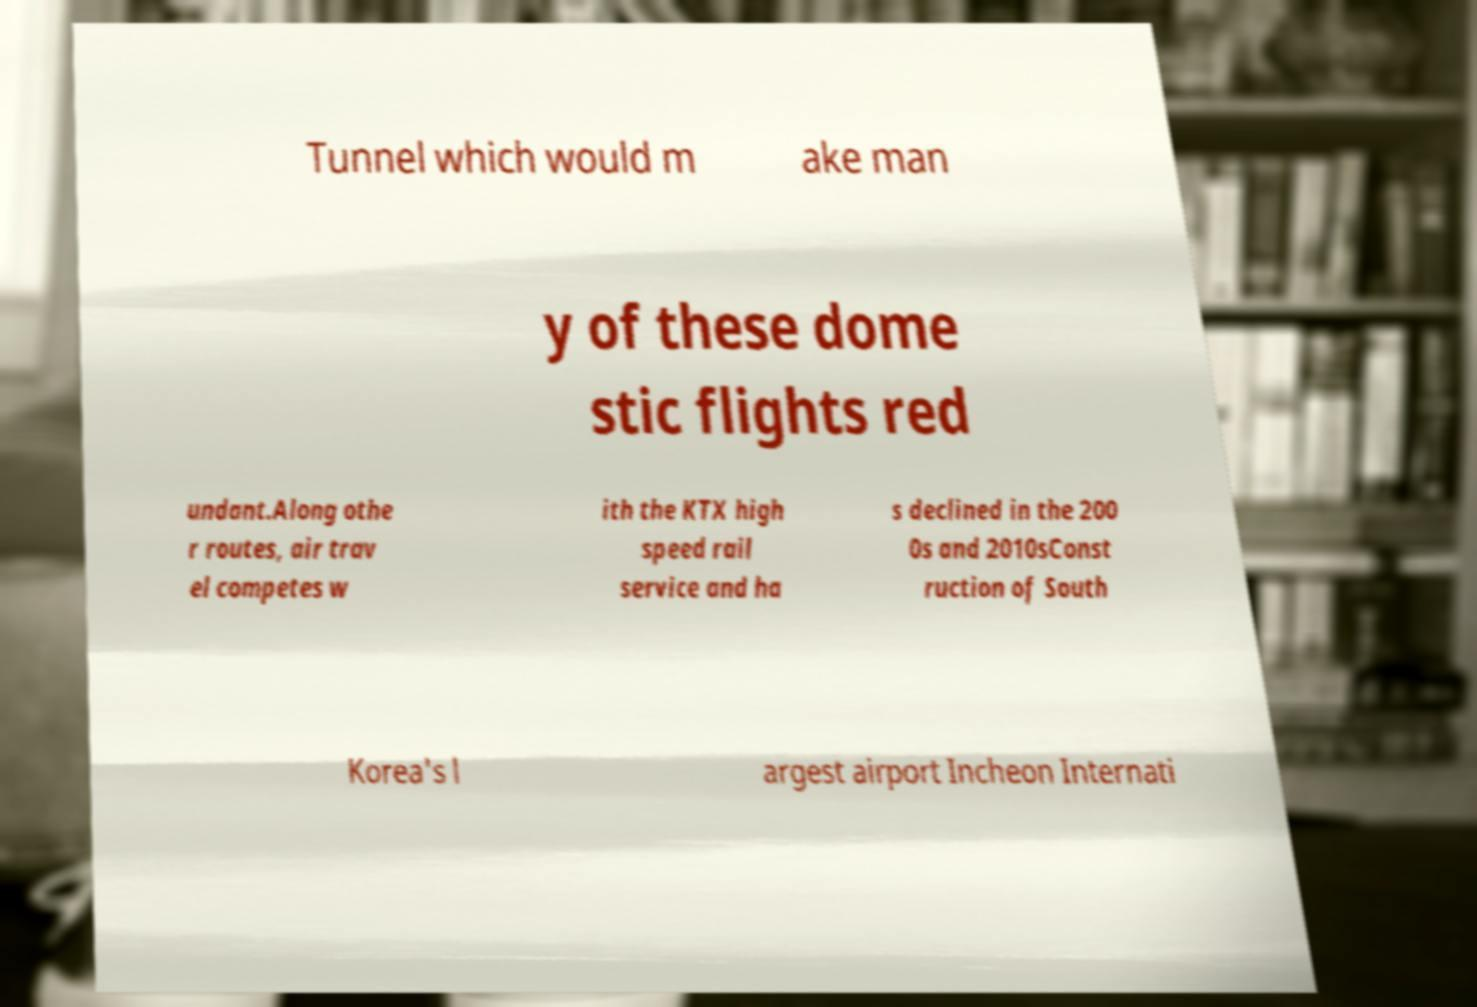What messages or text are displayed in this image? I need them in a readable, typed format. Tunnel which would m ake man y of these dome stic flights red undant.Along othe r routes, air trav el competes w ith the KTX high speed rail service and ha s declined in the 200 0s and 2010sConst ruction of South Korea's l argest airport Incheon Internati 